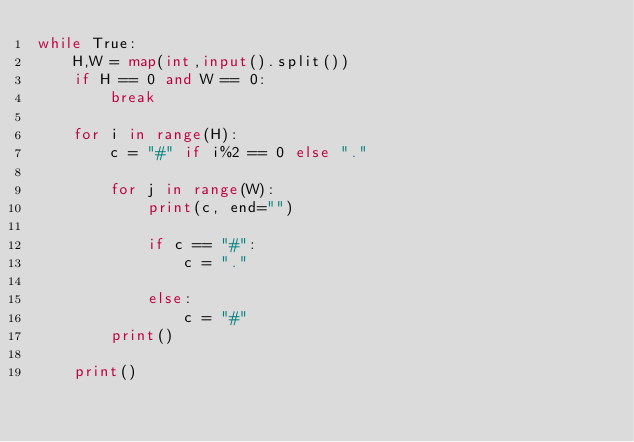<code> <loc_0><loc_0><loc_500><loc_500><_Python_>while True:
    H,W = map(int,input().split())
    if H == 0 and W == 0:
        break

    for i in range(H):
        c = "#" if i%2 == 0 else "."

        for j in range(W):
            print(c, end="")

            if c == "#":
                c = "."

            else:
                c = "#"
        print()

    print()
</code> 